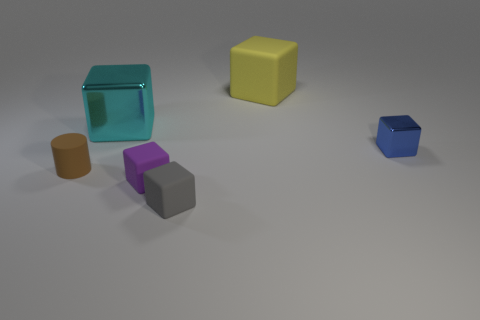Is the material of the thing right of the large matte object the same as the block that is on the left side of the tiny purple cube?
Ensure brevity in your answer.  Yes. Is the number of cyan metallic cubes on the right side of the gray rubber block less than the number of large yellow objects?
Your response must be concise. Yes. There is a rubber block that is behind the tiny brown matte cylinder; what is its color?
Provide a short and direct response. Yellow. What is the material of the tiny thing that is to the left of the purple rubber block in front of the tiny blue metal cube?
Your answer should be very brief. Rubber. Are there any blue rubber cylinders that have the same size as the blue metal object?
Offer a very short reply. No. What number of objects are small blue cubes on the right side of the small gray thing or rubber blocks that are in front of the rubber cylinder?
Provide a short and direct response. 3. Is the size of the metallic block behind the blue block the same as the metal thing that is right of the cyan metallic object?
Your answer should be very brief. No. Is there a big cube that is behind the matte thing behind the brown rubber object?
Keep it short and to the point. No. There is a tiny brown thing; how many tiny matte objects are on the right side of it?
Offer a very short reply. 2. What number of other objects are there of the same color as the tiny shiny thing?
Ensure brevity in your answer.  0. 